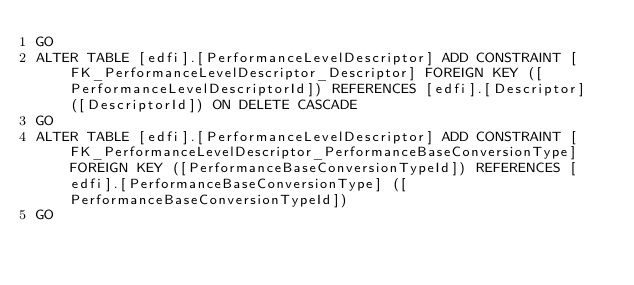Convert code to text. <code><loc_0><loc_0><loc_500><loc_500><_SQL_>GO
ALTER TABLE [edfi].[PerformanceLevelDescriptor] ADD CONSTRAINT [FK_PerformanceLevelDescriptor_Descriptor] FOREIGN KEY ([PerformanceLevelDescriptorId]) REFERENCES [edfi].[Descriptor] ([DescriptorId]) ON DELETE CASCADE
GO
ALTER TABLE [edfi].[PerformanceLevelDescriptor] ADD CONSTRAINT [FK_PerformanceLevelDescriptor_PerformanceBaseConversionType] FOREIGN KEY ([PerformanceBaseConversionTypeId]) REFERENCES [edfi].[PerformanceBaseConversionType] ([PerformanceBaseConversionTypeId])
GO
</code> 